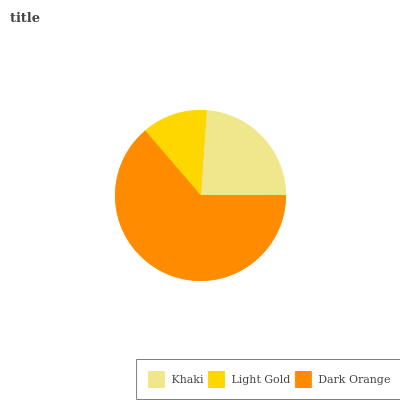Is Light Gold the minimum?
Answer yes or no. Yes. Is Dark Orange the maximum?
Answer yes or no. Yes. Is Dark Orange the minimum?
Answer yes or no. No. Is Light Gold the maximum?
Answer yes or no. No. Is Dark Orange greater than Light Gold?
Answer yes or no. Yes. Is Light Gold less than Dark Orange?
Answer yes or no. Yes. Is Light Gold greater than Dark Orange?
Answer yes or no. No. Is Dark Orange less than Light Gold?
Answer yes or no. No. Is Khaki the high median?
Answer yes or no. Yes. Is Khaki the low median?
Answer yes or no. Yes. Is Dark Orange the high median?
Answer yes or no. No. Is Dark Orange the low median?
Answer yes or no. No. 